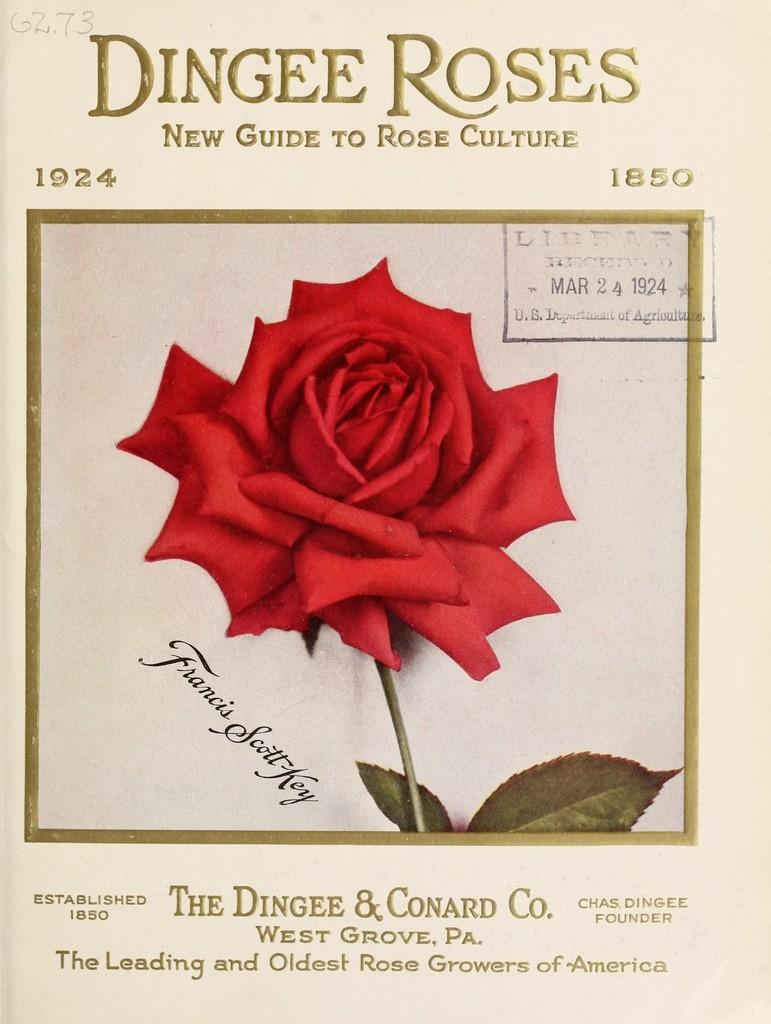What is the main subject of the image? The main subject of the image is a paper photo of a red rose. What words are written at the top of the image? The words "Dingee Roses" are written at the top of the image. What type of bird can be seen in the image? There is no bird present in the image; it features a paper photo of a red rose with the words "Dingee Roses" written at the top. 